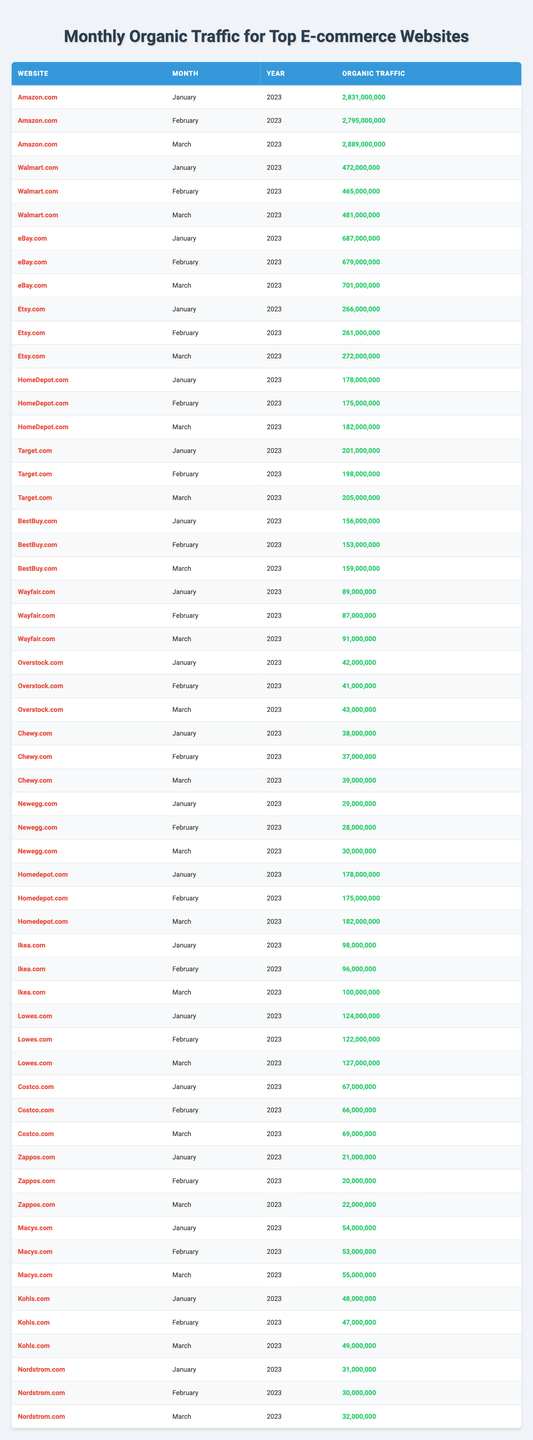What was the organic traffic for Amazon.com in March 2023? The table shows that for Amazon.com the organic traffic in March 2023 was 2,889,000,000.
Answer: 2,889,000,000 Which website had the highest organic traffic in January 2023? By comparing the values, Amazon.com had the highest organic traffic in January 2023 with 2,831,000,000.
Answer: Amazon.com What is the total organic traffic for eBay.com across the three months? For eBay.com, the organic traffic across the three months is 687,000,000 (January) + 679,000,000 (February) + 701,000,000 (March) = 2,067,000,000.
Answer: 2,067,000,000 What is the average organic traffic for Target.com in the first quarter of 2023? The values for Target.com are 201,000,000 (January), 198,000,000 (February), and 205,000,000 (March). Their sum is 604,000,000, and dividing by 3 gives an average of 201,333,333.
Answer: 201,333,333 Which website saw the smallest organic traffic in February 2023? Comparing the February traffic, Overstock.com had the smallest at 41,000,000.
Answer: Overstock.com Did Chewy.com experience an increase in organic traffic from January to March 2023? The organic traffic for Chewy.com was 38,000,000 in January, increased to 39,000,000 in March, confirming an increase.
Answer: Yes Which e-commerce website had the most consistent traffic across the three months? By assessing the monthly figures, Walmart.com shows little variation, with values only slightly fluctuating from 472,000,000 to 481,000,000, indicating consistency.
Answer: Walmart.com What is the percentage growth in organic traffic for Ikea.com from January to March 2023? Starting from 98,000,000 in January to 100,000,000 in March, the growth is (100,000,000 - 98,000,000) / 98,000,000 * 100 = approximately 2.04%.
Answer: Approximately 2.04% If you consolidate the organic traffic of HomeDepot.com from January to March, how much traffic did they generate altogether? The total organic traffic for HomeDepot.com over the three months is 178,000,000 (January) + 175,000,000 (February) + 182,000,000 (March) = 535,000,000.
Answer: 535,000,000 Is the organic traffic for Lowes.com higher in March than that of Zappos.com? For Lowes.com, the traffic in March was 127,000,000, while for Zappos.com it was 22,000,000, therefore Lowes.com had higher traffic.
Answer: Yes Which website's traffic increased by more than 10 million from January to March? Comparing the data, eBay.com increased from 687,000,000 in January to 701,000,000 in March, an increase of 14,000,000.
Answer: eBay.com 